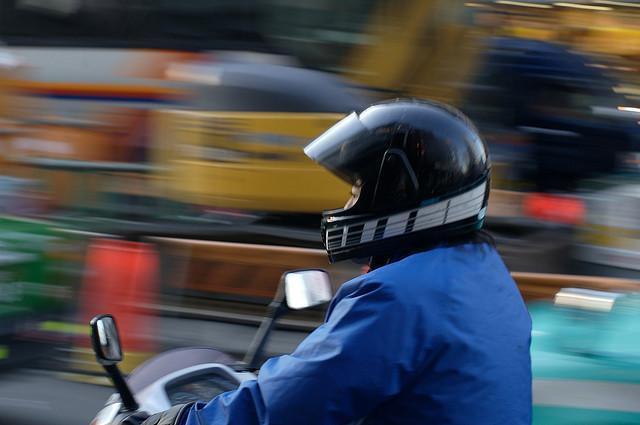How many mirrors in the photo?
Give a very brief answer. 2. 